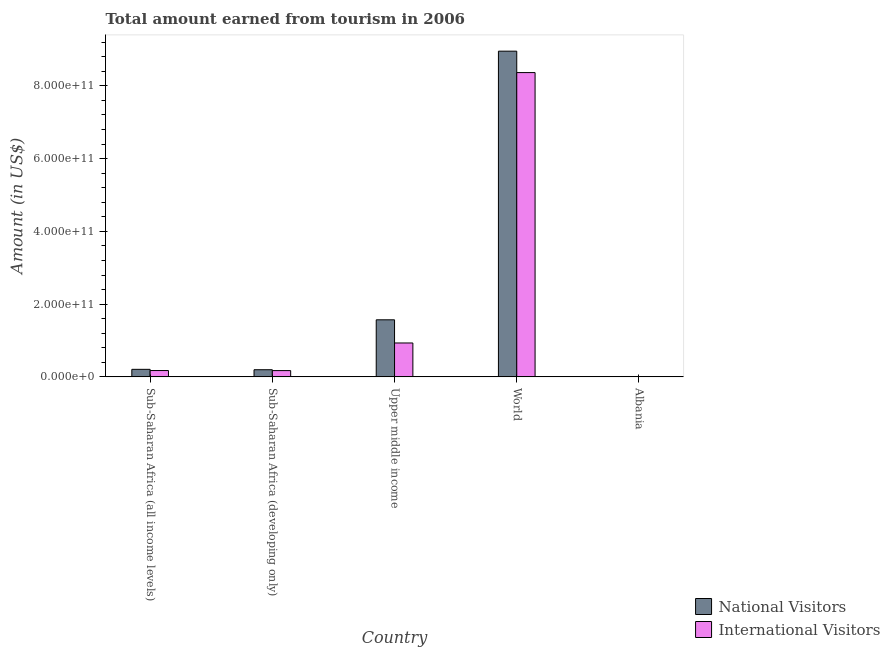How many groups of bars are there?
Make the answer very short. 5. Are the number of bars per tick equal to the number of legend labels?
Your answer should be compact. Yes. Are the number of bars on each tick of the X-axis equal?
Ensure brevity in your answer.  Yes. How many bars are there on the 2nd tick from the left?
Offer a very short reply. 2. What is the amount earned from national visitors in Albania?
Make the answer very short. 1.06e+09. Across all countries, what is the maximum amount earned from international visitors?
Provide a succinct answer. 8.36e+11. Across all countries, what is the minimum amount earned from national visitors?
Provide a short and direct response. 1.06e+09. In which country was the amount earned from national visitors minimum?
Offer a very short reply. Albania. What is the total amount earned from international visitors in the graph?
Offer a very short reply. 9.65e+11. What is the difference between the amount earned from international visitors in Sub-Saharan Africa (all income levels) and that in Upper middle income?
Your response must be concise. -7.58e+1. What is the difference between the amount earned from international visitors in Upper middle income and the amount earned from national visitors in World?
Make the answer very short. -8.02e+11. What is the average amount earned from international visitors per country?
Make the answer very short. 1.93e+11. What is the difference between the amount earned from international visitors and amount earned from national visitors in Albania?
Offer a terse response. -6.80e+07. In how many countries, is the amount earned from national visitors greater than 440000000000 US$?
Your answer should be compact. 1. What is the ratio of the amount earned from national visitors in Albania to that in Sub-Saharan Africa (developing only)?
Your answer should be compact. 0.05. What is the difference between the highest and the second highest amount earned from international visitors?
Your response must be concise. 7.43e+11. What is the difference between the highest and the lowest amount earned from international visitors?
Offer a terse response. 8.35e+11. In how many countries, is the amount earned from international visitors greater than the average amount earned from international visitors taken over all countries?
Your answer should be very brief. 1. Is the sum of the amount earned from international visitors in Sub-Saharan Africa (all income levels) and Sub-Saharan Africa (developing only) greater than the maximum amount earned from national visitors across all countries?
Provide a short and direct response. No. What does the 2nd bar from the left in Upper middle income represents?
Your response must be concise. International Visitors. What does the 1st bar from the right in Albania represents?
Your answer should be compact. International Visitors. What is the difference between two consecutive major ticks on the Y-axis?
Offer a terse response. 2.00e+11. Are the values on the major ticks of Y-axis written in scientific E-notation?
Your response must be concise. Yes. Does the graph contain grids?
Offer a very short reply. No. How many legend labels are there?
Offer a terse response. 2. How are the legend labels stacked?
Your response must be concise. Vertical. What is the title of the graph?
Keep it short and to the point. Total amount earned from tourism in 2006. Does "Exports of goods" appear as one of the legend labels in the graph?
Provide a short and direct response. No. What is the label or title of the Y-axis?
Your response must be concise. Amount (in US$). What is the Amount (in US$) in National Visitors in Sub-Saharan Africa (all income levels)?
Make the answer very short. 2.07e+1. What is the Amount (in US$) of International Visitors in Sub-Saharan Africa (all income levels)?
Offer a terse response. 1.74e+1. What is the Amount (in US$) of National Visitors in Sub-Saharan Africa (developing only)?
Offer a very short reply. 1.97e+1. What is the Amount (in US$) of International Visitors in Sub-Saharan Africa (developing only)?
Provide a succinct answer. 1.72e+1. What is the Amount (in US$) in National Visitors in Upper middle income?
Make the answer very short. 1.57e+11. What is the Amount (in US$) of International Visitors in Upper middle income?
Your answer should be very brief. 9.32e+1. What is the Amount (in US$) of National Visitors in World?
Keep it short and to the point. 8.95e+11. What is the Amount (in US$) in International Visitors in World?
Provide a succinct answer. 8.36e+11. What is the Amount (in US$) of National Visitors in Albania?
Provide a short and direct response. 1.06e+09. What is the Amount (in US$) in International Visitors in Albania?
Your response must be concise. 9.89e+08. Across all countries, what is the maximum Amount (in US$) of National Visitors?
Provide a short and direct response. 8.95e+11. Across all countries, what is the maximum Amount (in US$) of International Visitors?
Your answer should be compact. 8.36e+11. Across all countries, what is the minimum Amount (in US$) in National Visitors?
Give a very brief answer. 1.06e+09. Across all countries, what is the minimum Amount (in US$) of International Visitors?
Offer a very short reply. 9.89e+08. What is the total Amount (in US$) in National Visitors in the graph?
Your answer should be very brief. 1.09e+12. What is the total Amount (in US$) in International Visitors in the graph?
Provide a succinct answer. 9.65e+11. What is the difference between the Amount (in US$) of National Visitors in Sub-Saharan Africa (all income levels) and that in Sub-Saharan Africa (developing only)?
Your response must be concise. 1.07e+09. What is the difference between the Amount (in US$) in International Visitors in Sub-Saharan Africa (all income levels) and that in Sub-Saharan Africa (developing only)?
Ensure brevity in your answer.  1.86e+08. What is the difference between the Amount (in US$) in National Visitors in Sub-Saharan Africa (all income levels) and that in Upper middle income?
Make the answer very short. -1.36e+11. What is the difference between the Amount (in US$) of International Visitors in Sub-Saharan Africa (all income levels) and that in Upper middle income?
Make the answer very short. -7.58e+1. What is the difference between the Amount (in US$) in National Visitors in Sub-Saharan Africa (all income levels) and that in World?
Keep it short and to the point. -8.75e+11. What is the difference between the Amount (in US$) of International Visitors in Sub-Saharan Africa (all income levels) and that in World?
Offer a terse response. -8.19e+11. What is the difference between the Amount (in US$) in National Visitors in Sub-Saharan Africa (all income levels) and that in Albania?
Your answer should be very brief. 1.97e+1. What is the difference between the Amount (in US$) of International Visitors in Sub-Saharan Africa (all income levels) and that in Albania?
Offer a very short reply. 1.64e+1. What is the difference between the Amount (in US$) of National Visitors in Sub-Saharan Africa (developing only) and that in Upper middle income?
Offer a terse response. -1.37e+11. What is the difference between the Amount (in US$) in International Visitors in Sub-Saharan Africa (developing only) and that in Upper middle income?
Keep it short and to the point. -7.59e+1. What is the difference between the Amount (in US$) in National Visitors in Sub-Saharan Africa (developing only) and that in World?
Make the answer very short. -8.76e+11. What is the difference between the Amount (in US$) in International Visitors in Sub-Saharan Africa (developing only) and that in World?
Your answer should be compact. -8.19e+11. What is the difference between the Amount (in US$) of National Visitors in Sub-Saharan Africa (developing only) and that in Albania?
Give a very brief answer. 1.86e+1. What is the difference between the Amount (in US$) in International Visitors in Sub-Saharan Africa (developing only) and that in Albania?
Offer a very short reply. 1.62e+1. What is the difference between the Amount (in US$) of National Visitors in Upper middle income and that in World?
Your response must be concise. -7.39e+11. What is the difference between the Amount (in US$) of International Visitors in Upper middle income and that in World?
Keep it short and to the point. -7.43e+11. What is the difference between the Amount (in US$) of National Visitors in Upper middle income and that in Albania?
Provide a short and direct response. 1.56e+11. What is the difference between the Amount (in US$) in International Visitors in Upper middle income and that in Albania?
Provide a succinct answer. 9.22e+1. What is the difference between the Amount (in US$) in National Visitors in World and that in Albania?
Your answer should be compact. 8.94e+11. What is the difference between the Amount (in US$) of International Visitors in World and that in Albania?
Offer a terse response. 8.35e+11. What is the difference between the Amount (in US$) of National Visitors in Sub-Saharan Africa (all income levels) and the Amount (in US$) of International Visitors in Sub-Saharan Africa (developing only)?
Your answer should be very brief. 3.49e+09. What is the difference between the Amount (in US$) of National Visitors in Sub-Saharan Africa (all income levels) and the Amount (in US$) of International Visitors in Upper middle income?
Keep it short and to the point. -7.25e+1. What is the difference between the Amount (in US$) in National Visitors in Sub-Saharan Africa (all income levels) and the Amount (in US$) in International Visitors in World?
Offer a terse response. -8.16e+11. What is the difference between the Amount (in US$) in National Visitors in Sub-Saharan Africa (all income levels) and the Amount (in US$) in International Visitors in Albania?
Ensure brevity in your answer.  1.97e+1. What is the difference between the Amount (in US$) of National Visitors in Sub-Saharan Africa (developing only) and the Amount (in US$) of International Visitors in Upper middle income?
Your response must be concise. -7.35e+1. What is the difference between the Amount (in US$) in National Visitors in Sub-Saharan Africa (developing only) and the Amount (in US$) in International Visitors in World?
Offer a terse response. -8.17e+11. What is the difference between the Amount (in US$) in National Visitors in Sub-Saharan Africa (developing only) and the Amount (in US$) in International Visitors in Albania?
Your answer should be very brief. 1.87e+1. What is the difference between the Amount (in US$) of National Visitors in Upper middle income and the Amount (in US$) of International Visitors in World?
Your answer should be compact. -6.80e+11. What is the difference between the Amount (in US$) of National Visitors in Upper middle income and the Amount (in US$) of International Visitors in Albania?
Offer a very short reply. 1.56e+11. What is the difference between the Amount (in US$) in National Visitors in World and the Amount (in US$) in International Visitors in Albania?
Ensure brevity in your answer.  8.94e+11. What is the average Amount (in US$) in National Visitors per country?
Offer a very short reply. 2.19e+11. What is the average Amount (in US$) of International Visitors per country?
Offer a terse response. 1.93e+11. What is the difference between the Amount (in US$) of National Visitors and Amount (in US$) of International Visitors in Sub-Saharan Africa (all income levels)?
Provide a short and direct response. 3.30e+09. What is the difference between the Amount (in US$) in National Visitors and Amount (in US$) in International Visitors in Sub-Saharan Africa (developing only)?
Make the answer very short. 2.42e+09. What is the difference between the Amount (in US$) of National Visitors and Amount (in US$) of International Visitors in Upper middle income?
Offer a very short reply. 6.37e+1. What is the difference between the Amount (in US$) of National Visitors and Amount (in US$) of International Visitors in World?
Provide a short and direct response. 5.89e+1. What is the difference between the Amount (in US$) in National Visitors and Amount (in US$) in International Visitors in Albania?
Your answer should be compact. 6.80e+07. What is the ratio of the Amount (in US$) in National Visitors in Sub-Saharan Africa (all income levels) to that in Sub-Saharan Africa (developing only)?
Provide a short and direct response. 1.05. What is the ratio of the Amount (in US$) of International Visitors in Sub-Saharan Africa (all income levels) to that in Sub-Saharan Africa (developing only)?
Give a very brief answer. 1.01. What is the ratio of the Amount (in US$) in National Visitors in Sub-Saharan Africa (all income levels) to that in Upper middle income?
Keep it short and to the point. 0.13. What is the ratio of the Amount (in US$) in International Visitors in Sub-Saharan Africa (all income levels) to that in Upper middle income?
Offer a terse response. 0.19. What is the ratio of the Amount (in US$) in National Visitors in Sub-Saharan Africa (all income levels) to that in World?
Keep it short and to the point. 0.02. What is the ratio of the Amount (in US$) in International Visitors in Sub-Saharan Africa (all income levels) to that in World?
Your answer should be very brief. 0.02. What is the ratio of the Amount (in US$) in National Visitors in Sub-Saharan Africa (all income levels) to that in Albania?
Provide a succinct answer. 19.61. What is the ratio of the Amount (in US$) of International Visitors in Sub-Saharan Africa (all income levels) to that in Albania?
Your answer should be very brief. 17.62. What is the ratio of the Amount (in US$) in National Visitors in Sub-Saharan Africa (developing only) to that in Upper middle income?
Make the answer very short. 0.13. What is the ratio of the Amount (in US$) of International Visitors in Sub-Saharan Africa (developing only) to that in Upper middle income?
Offer a very short reply. 0.18. What is the ratio of the Amount (in US$) in National Visitors in Sub-Saharan Africa (developing only) to that in World?
Ensure brevity in your answer.  0.02. What is the ratio of the Amount (in US$) in International Visitors in Sub-Saharan Africa (developing only) to that in World?
Your answer should be compact. 0.02. What is the ratio of the Amount (in US$) of National Visitors in Sub-Saharan Africa (developing only) to that in Albania?
Ensure brevity in your answer.  18.6. What is the ratio of the Amount (in US$) in International Visitors in Sub-Saharan Africa (developing only) to that in Albania?
Ensure brevity in your answer.  17.43. What is the ratio of the Amount (in US$) of National Visitors in Upper middle income to that in World?
Your answer should be compact. 0.18. What is the ratio of the Amount (in US$) of International Visitors in Upper middle income to that in World?
Make the answer very short. 0.11. What is the ratio of the Amount (in US$) of National Visitors in Upper middle income to that in Albania?
Your answer should be compact. 148.41. What is the ratio of the Amount (in US$) in International Visitors in Upper middle income to that in Albania?
Offer a very short reply. 94.22. What is the ratio of the Amount (in US$) of National Visitors in World to that in Albania?
Your response must be concise. 847.1. What is the ratio of the Amount (in US$) in International Visitors in World to that in Albania?
Make the answer very short. 845.78. What is the difference between the highest and the second highest Amount (in US$) in National Visitors?
Offer a terse response. 7.39e+11. What is the difference between the highest and the second highest Amount (in US$) in International Visitors?
Provide a short and direct response. 7.43e+11. What is the difference between the highest and the lowest Amount (in US$) in National Visitors?
Provide a succinct answer. 8.94e+11. What is the difference between the highest and the lowest Amount (in US$) in International Visitors?
Your response must be concise. 8.35e+11. 